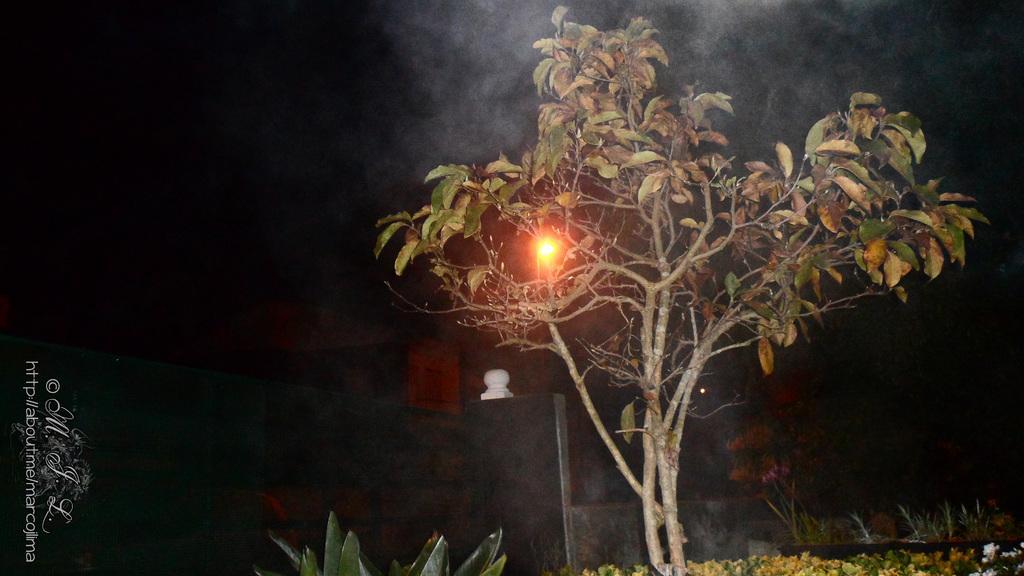How would you summarize this image in a sentence or two? In this image we can see a tree, there are plants, there is a light, there is a sky, there it is dark. 